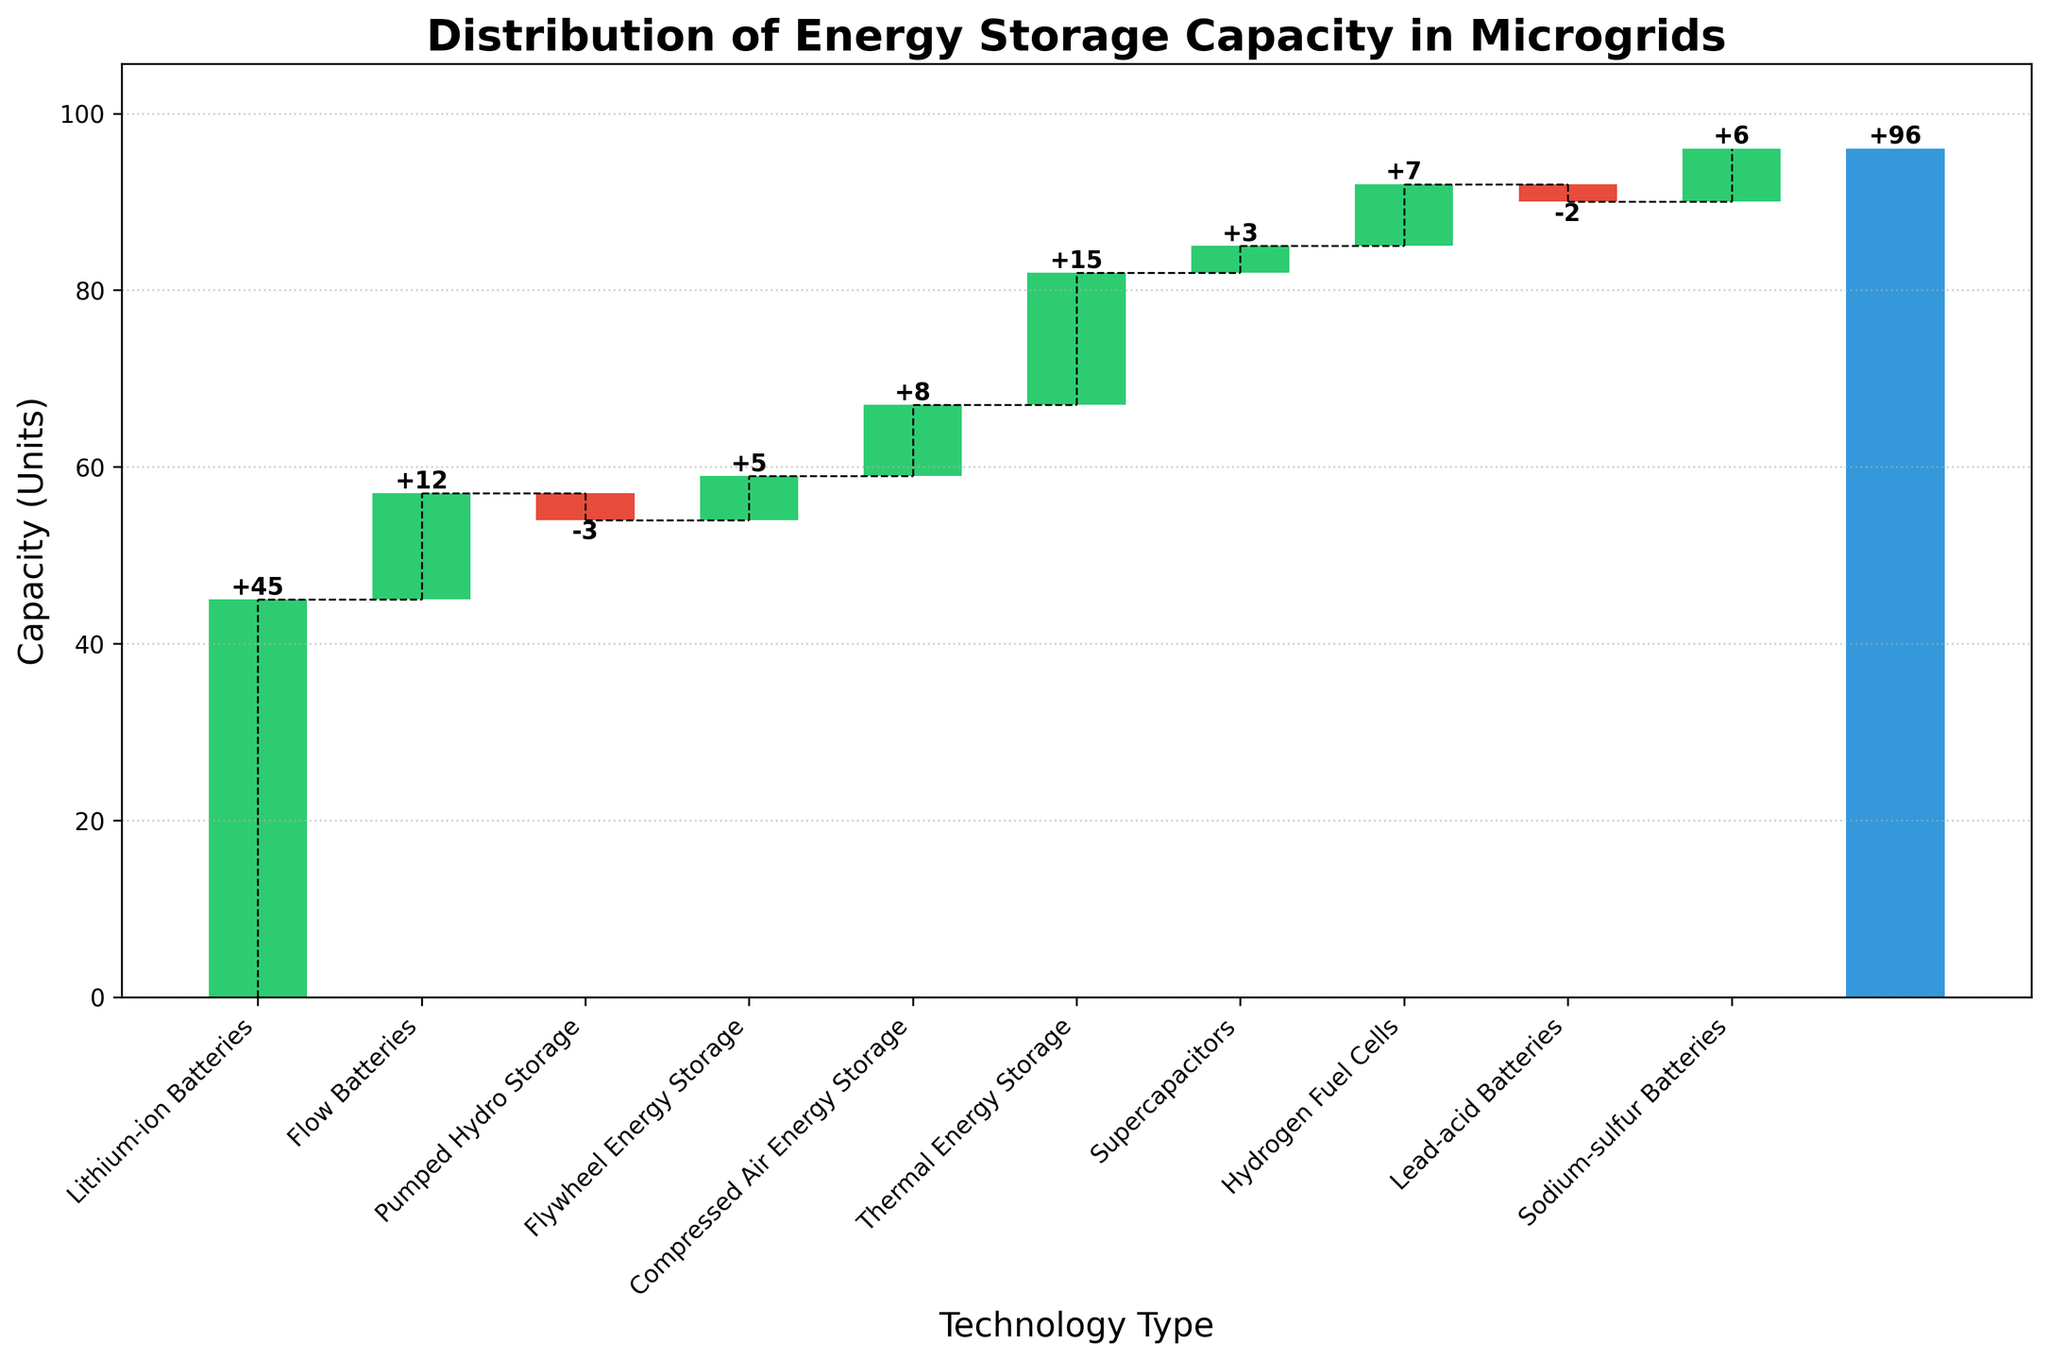Which technology type has the highest energy storage capacity? Refer to the bar heights in the chart. The tallest bar represents the technology with the highest capacity, which is Lithium-ion Batteries.
Answer: Lithium-ion Batteries Which two technology types have negative energy storage capacities? Check for bars that drop below the baseline. The categories Pumped Hydro Storage and Lead-acid Batteries have negative values.
Answer: Pumped Hydro Storage, Lead-acid Batteries How much is the combined energy storage capacity of Thermal Energy Storage, Flywheel Energy Storage, and Hydrogen Fuel Cells? Sum their values: 15 (Thermal Energy Storage) + 5 (Flywheel Energy Storage) + 7 (Hydrogen Fuel Cells) = 27.
Answer: 27 What is the difference in energy storage capacity between Compressed Air Energy Storage and Flow Batteries? Subtract the value of Flow Batteries from Compressed Air Energy Storage: 8 (Compressed Air Energy Storage) - 12 (Flow Batteries) = -4.
Answer: -4 How does the capacity of Sodium-sulfur Batteries compare to that of Flow Batteries? Look at their heights. Flow Batteries have 12 units, while Sodium-sulfur Batteries have 6 units, making Flow Batteries' capacity higher.
Answer: Less How many technology types have a higher storage capacity than Flywheel Energy Storage? Compare Flywheel Energy Storage's value (5) with others. Those higher include: Lithium-ion Batteries, Thermal Energy Storage, Compressed Air Energy Storage, and Flow Batteries. Four types have higher capacity.
Answer: 4 What is the total energy storage capacity for all technologies combined? The total is given at the end of the chart, which is 96.
Answer: 96 By how much does the capacity of Lithium-ion Batteries exceed that of Supercapacitors? Subtract Supercapacitors' value from Lithium-ion Batteries: 45 (Lithium-ion Batteries) - 3 (Supercapacitors) = 42.
Answer: 42 Which technology type has the closest energy storage capacity to the average capacity across all the technologies? Calculate the average first: (Sum of capacities) / (Number of technologies) = 45+12-3+5+8+15+3+7-2+6 / 10 = 9.6. Compressed Air Energy Storage has the closest value to this average with 8 units.
Answer: Compressed Air Energy Storage 